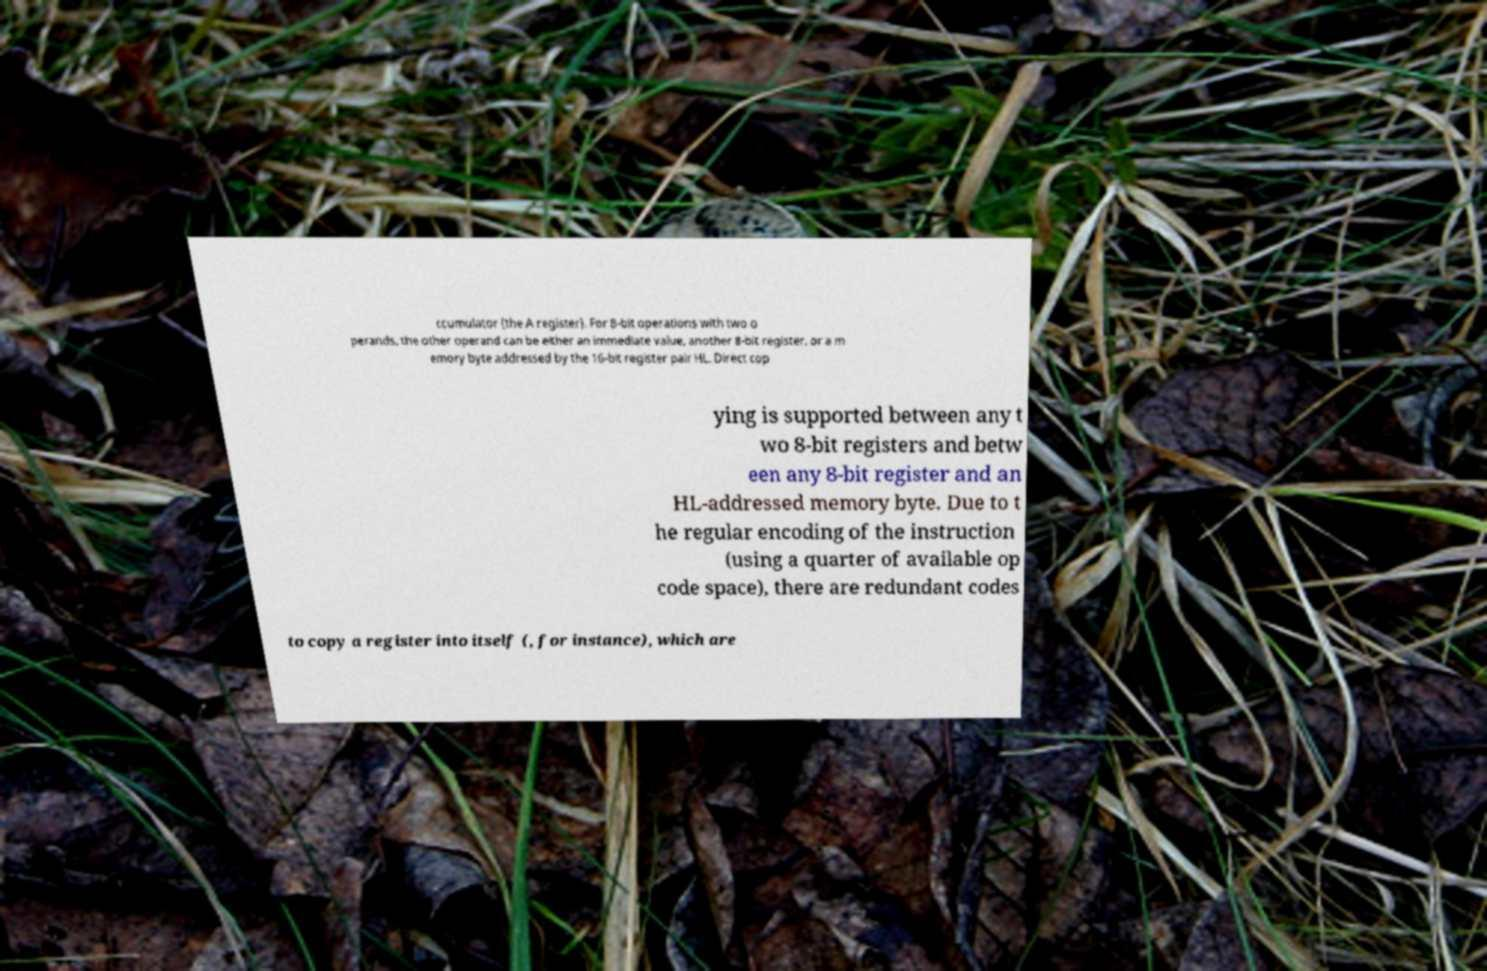Can you accurately transcribe the text from the provided image for me? ccumulator (the A register). For 8-bit operations with two o perands, the other operand can be either an immediate value, another 8-bit register, or a m emory byte addressed by the 16-bit register pair HL. Direct cop ying is supported between any t wo 8-bit registers and betw een any 8-bit register and an HL-addressed memory byte. Due to t he regular encoding of the instruction (using a quarter of available op code space), there are redundant codes to copy a register into itself (, for instance), which are 